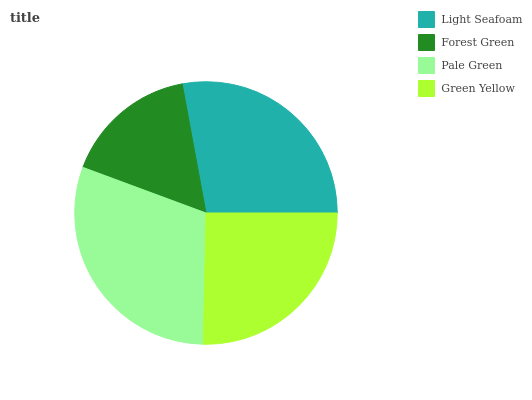Is Forest Green the minimum?
Answer yes or no. Yes. Is Pale Green the maximum?
Answer yes or no. Yes. Is Pale Green the minimum?
Answer yes or no. No. Is Forest Green the maximum?
Answer yes or no. No. Is Pale Green greater than Forest Green?
Answer yes or no. Yes. Is Forest Green less than Pale Green?
Answer yes or no. Yes. Is Forest Green greater than Pale Green?
Answer yes or no. No. Is Pale Green less than Forest Green?
Answer yes or no. No. Is Light Seafoam the high median?
Answer yes or no. Yes. Is Green Yellow the low median?
Answer yes or no. Yes. Is Green Yellow the high median?
Answer yes or no. No. Is Light Seafoam the low median?
Answer yes or no. No. 